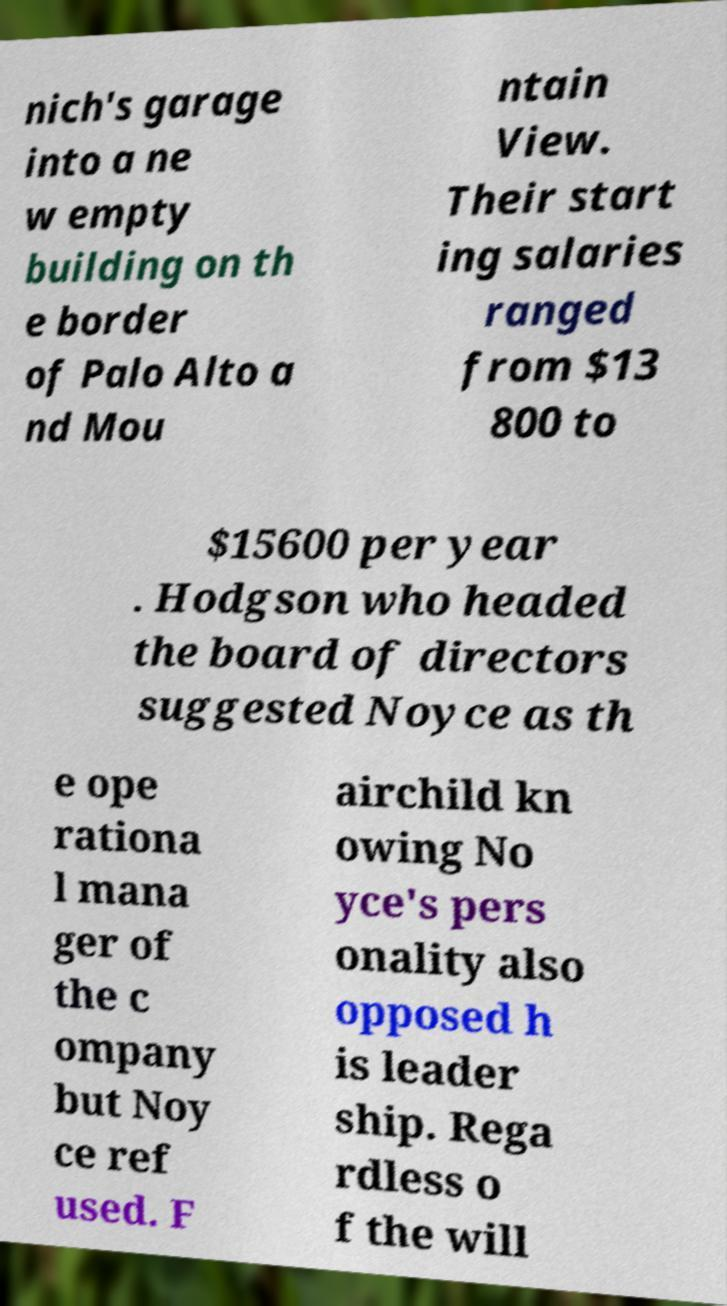Can you accurately transcribe the text from the provided image for me? nich's garage into a ne w empty building on th e border of Palo Alto a nd Mou ntain View. Their start ing salaries ranged from $13 800 to $15600 per year . Hodgson who headed the board of directors suggested Noyce as th e ope rationa l mana ger of the c ompany but Noy ce ref used. F airchild kn owing No yce's pers onality also opposed h is leader ship. Rega rdless o f the will 